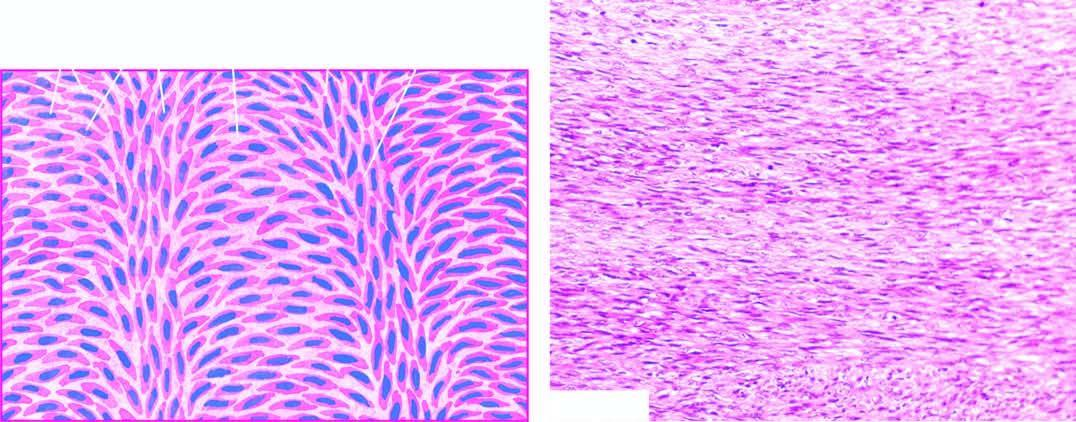does the necrotic tissue show a well-differentiated tumour composed of spindle-shaped cells forming interlacing fascicles producing a typical herring-bone pattern?
Answer the question using a single word or phrase. No 